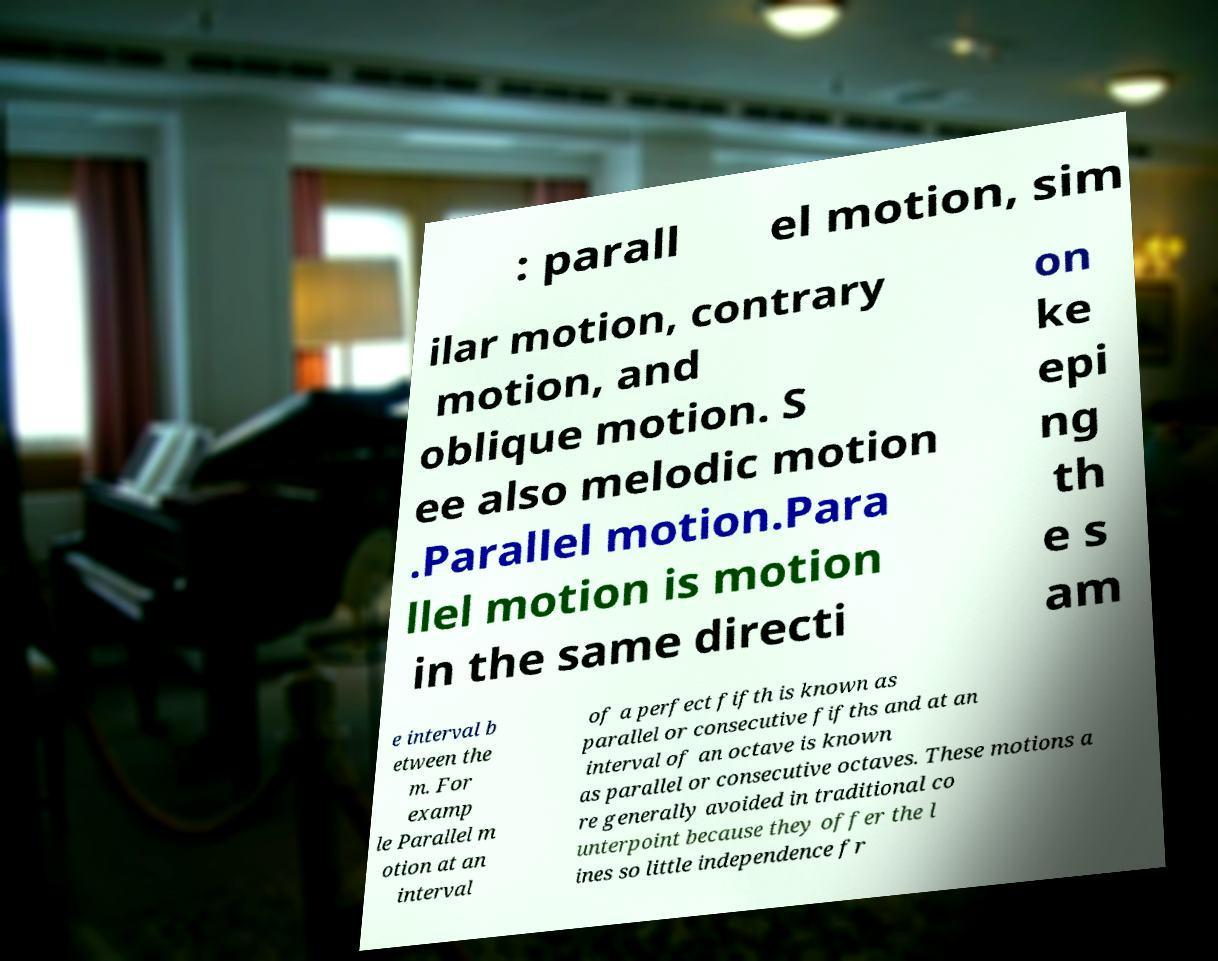Could you assist in decoding the text presented in this image and type it out clearly? : parall el motion, sim ilar motion, contrary motion, and oblique motion. S ee also melodic motion .Parallel motion.Para llel motion is motion in the same directi on ke epi ng th e s am e interval b etween the m. For examp le Parallel m otion at an interval of a perfect fifth is known as parallel or consecutive fifths and at an interval of an octave is known as parallel or consecutive octaves. These motions a re generally avoided in traditional co unterpoint because they offer the l ines so little independence fr 